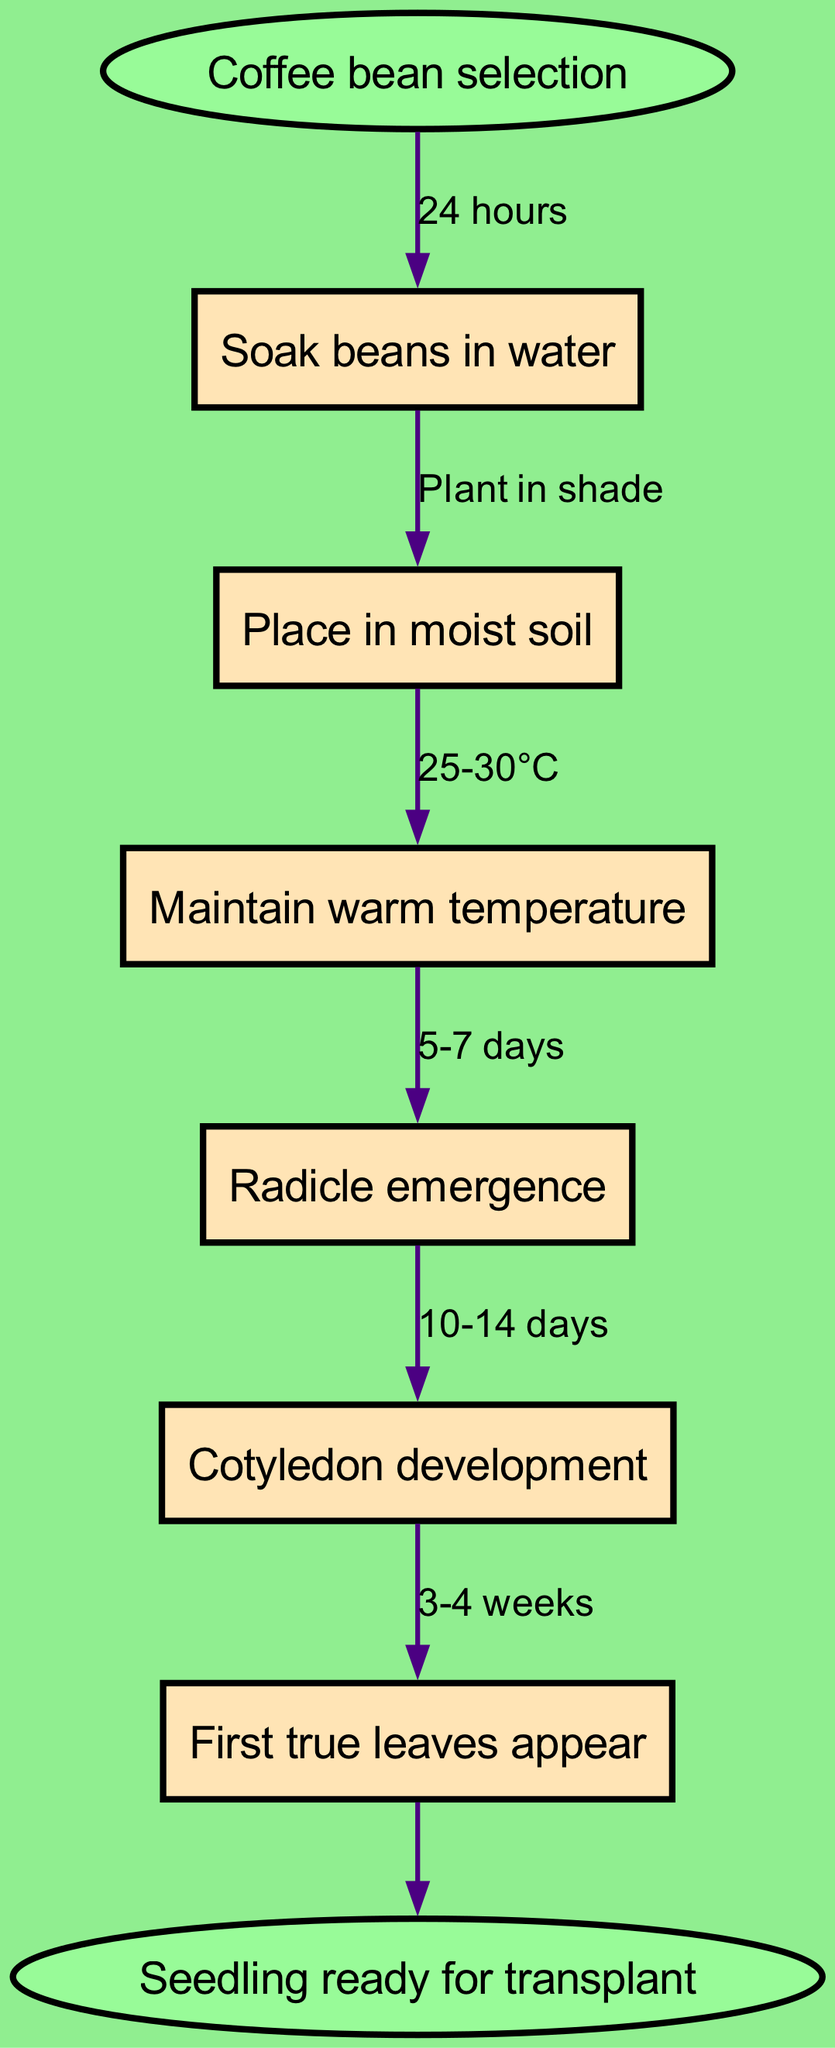What is the first stage in the germination process? The diagram indicates that the first stage is "Soak beans in water," which is the first node connected to the start point.
Answer: Soak beans in water How many nodes are present in the diagram? The diagram lists six specific stages (or nodes) in the germination process, thus counting six individual nodes.
Answer: 6 What temperature is recommended to maintain during germination? Referring to the diagram, the stage after placing beans in soil specifies to maintain a "25-30°C" temperature as indicated on the connecting edge.
Answer: 25-30°C What is the maximum time to see radicle emergence? The diagram states that radicle emergence occurs after "5-7 days," which is noted on the edge leading to that stage.
Answer: 5-7 days What is the final stage before transplanting the seedlings? According to the diagram, the last stage before transplanting is "Seedling ready for transplant," which is the endpoint of the flowchart.
Answer: Seedling ready for transplant Which stage requires placing the beans in moist soil? In the diagram, the stage that requires placing beans in moist soil follows the soaking stage, directly connected as the second node.
Answer: Place in moist soil Identify the edge label between ‘Cotyledon development’ and ‘First true leaves appear’. Looking at the diagram, the edge that connects these two stages indicates a time frame of "3-4 weeks," linking the development of cotyledons to the appearance of true leaves.
Answer: 3-4 weeks What do you do after soaking the beans in water? Following the flow of the diagram, after the soaking stage, the next step is to "Place in moist soil," which connects to the soaking node directly.
Answer: Place in moist soil What is the color of the start node in the diagram? The diagram specifies that the start node, which represents "Coffee bean selection," is colored light green, identifying it distinctly from other nodes.
Answer: Light green 